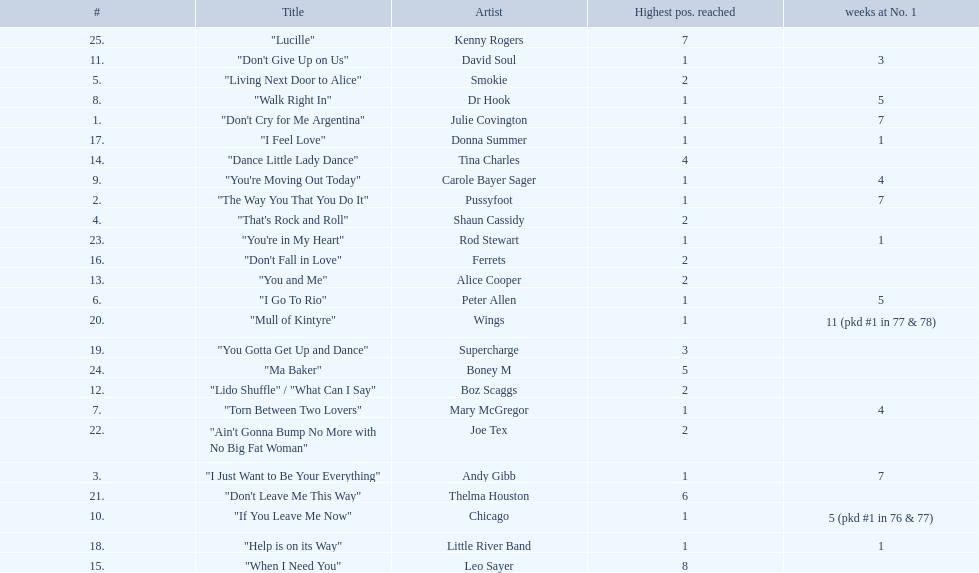Who had the one of the least weeks at number one? Rod Stewart. Who had no week at number one? Shaun Cassidy. Who had the highest number of weeks at number one? Wings. 